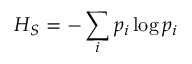Convert formula to latex. <formula><loc_0><loc_0><loc_500><loc_500>H _ { S } = - \sum _ { i } p _ { i } \log p _ { i }</formula> 